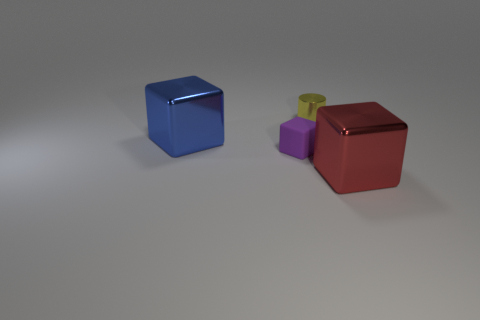Add 3 big red matte spheres. How many objects exist? 7 Subtract all cubes. How many objects are left? 1 Add 2 purple cubes. How many purple cubes exist? 3 Subtract 0 yellow blocks. How many objects are left? 4 Subtract all small purple matte cubes. Subtract all purple things. How many objects are left? 2 Add 4 large metal things. How many large metal things are left? 6 